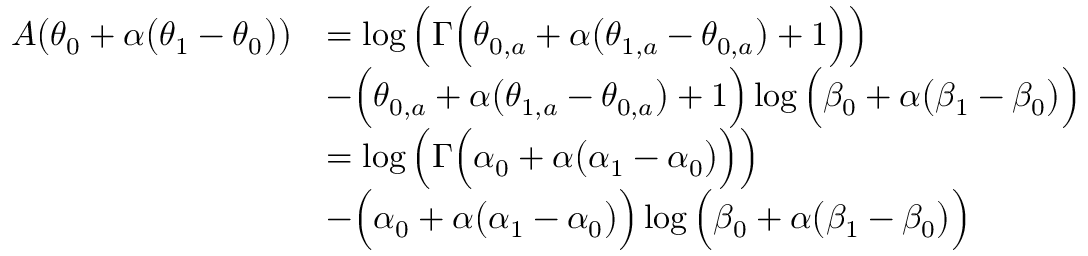Convert formula to latex. <formula><loc_0><loc_0><loc_500><loc_500>\begin{array} { r l } { A \left ( \theta _ { 0 } + \alpha \left ( \theta _ { 1 } - \theta _ { 0 } \right ) \right ) } & { = \log \left ( \Gamma \left ( \theta _ { 0 , a } + \alpha \left ( \theta _ { 1 , a } - \theta _ { 0 , a } \right ) + 1 \right ) \right ) } \\ & { - \left ( \theta _ { 0 , a } + \alpha \left ( \theta _ { 1 , a } - \theta _ { 0 , a } \right ) + 1 \right ) \log \left ( \beta _ { 0 } + \alpha \left ( \beta _ { 1 } - \beta _ { 0 } \right ) \right ) } \\ & { = \log \left ( \Gamma \left ( \alpha _ { 0 } + \alpha \left ( \alpha _ { 1 } - \alpha _ { 0 } \right ) \right ) \right ) } \\ & { - \left ( \alpha _ { 0 } + \alpha \left ( \alpha _ { 1 } - \alpha _ { 0 } \right ) \right ) \log \left ( \beta _ { 0 } + \alpha \left ( \beta _ { 1 } - \beta _ { 0 } \right ) \right ) } \end{array}</formula> 